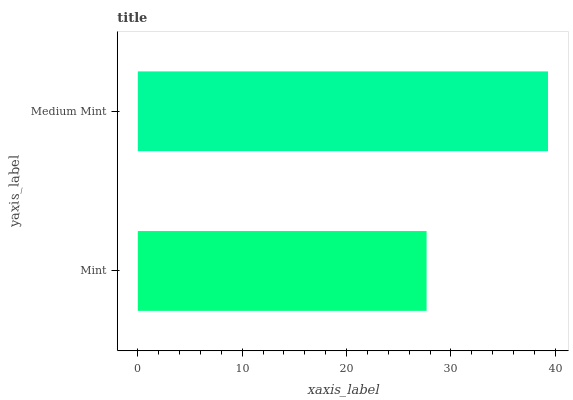Is Mint the minimum?
Answer yes or no. Yes. Is Medium Mint the maximum?
Answer yes or no. Yes. Is Medium Mint the minimum?
Answer yes or no. No. Is Medium Mint greater than Mint?
Answer yes or no. Yes. Is Mint less than Medium Mint?
Answer yes or no. Yes. Is Mint greater than Medium Mint?
Answer yes or no. No. Is Medium Mint less than Mint?
Answer yes or no. No. Is Medium Mint the high median?
Answer yes or no. Yes. Is Mint the low median?
Answer yes or no. Yes. Is Mint the high median?
Answer yes or no. No. Is Medium Mint the low median?
Answer yes or no. No. 